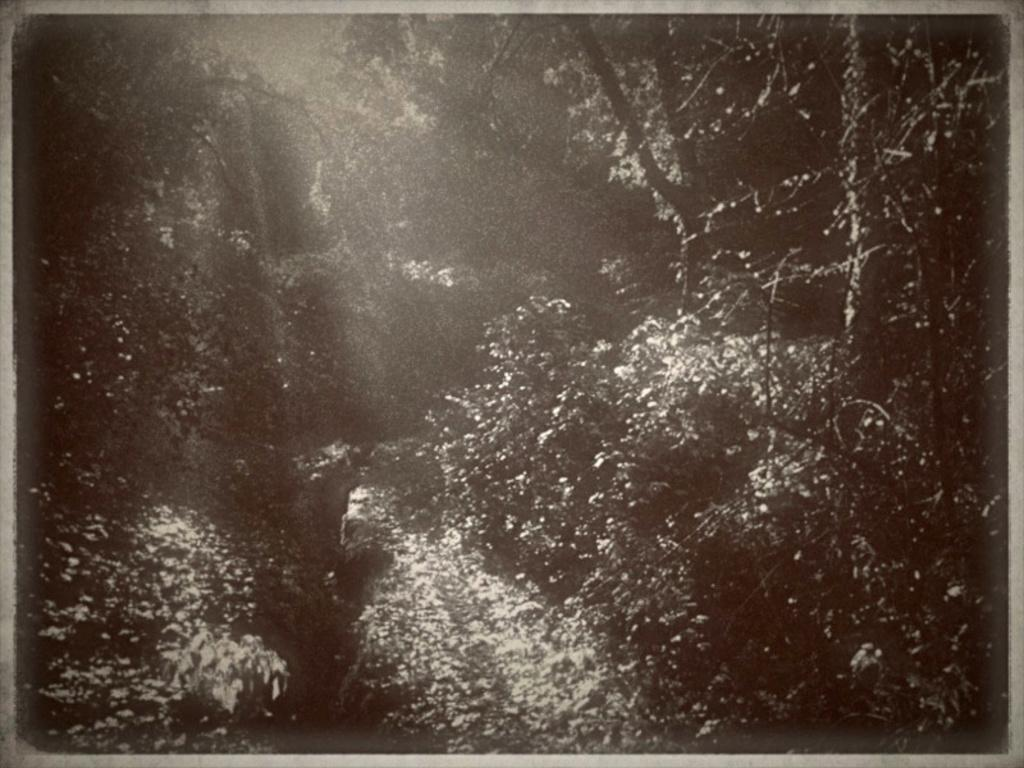What can be observed about the image's appearance? The image is edited. What type of natural elements are present in the image? There are trees in the image. Can you see any sidewalks in the image? There is no mention of a sidewalk in the provided facts, so it cannot be determined if one is present in the image. Are any animals biting the trees in the image? There is no indication of animals or biting in the provided facts, so it cannot be determined if this is happening in the image. 